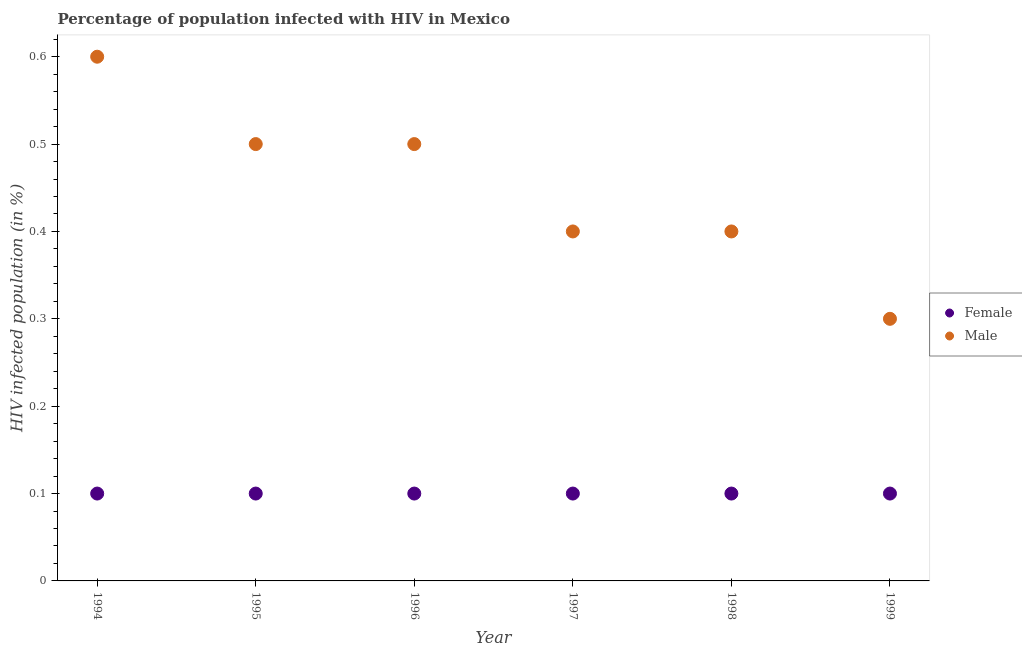How many different coloured dotlines are there?
Provide a short and direct response. 2. What is the percentage of males who are infected with hiv in 1997?
Give a very brief answer. 0.4. Across all years, what is the maximum percentage of males who are infected with hiv?
Offer a terse response. 0.6. Across all years, what is the minimum percentage of females who are infected with hiv?
Provide a short and direct response. 0.1. In which year was the percentage of females who are infected with hiv minimum?
Give a very brief answer. 1994. What is the total percentage of males who are infected with hiv in the graph?
Your response must be concise. 2.7. What is the difference between the percentage of males who are infected with hiv in 1994 and the percentage of females who are infected with hiv in 1996?
Provide a succinct answer. 0.5. What is the average percentage of males who are infected with hiv per year?
Make the answer very short. 0.45. In the year 1994, what is the difference between the percentage of females who are infected with hiv and percentage of males who are infected with hiv?
Offer a terse response. -0.5. In how many years, is the percentage of females who are infected with hiv greater than 0.16 %?
Make the answer very short. 0. Is the percentage of males who are infected with hiv in 1997 less than that in 1998?
Make the answer very short. No. Is the difference between the percentage of females who are infected with hiv in 1996 and 1998 greater than the difference between the percentage of males who are infected with hiv in 1996 and 1998?
Provide a succinct answer. No. What is the difference between the highest and the second highest percentage of females who are infected with hiv?
Your answer should be very brief. 0. What is the difference between the highest and the lowest percentage of males who are infected with hiv?
Give a very brief answer. 0.3. Is the sum of the percentage of males who are infected with hiv in 1996 and 1999 greater than the maximum percentage of females who are infected with hiv across all years?
Keep it short and to the point. Yes. Does the percentage of males who are infected with hiv monotonically increase over the years?
Your response must be concise. No. Is the percentage of males who are infected with hiv strictly greater than the percentage of females who are infected with hiv over the years?
Provide a succinct answer. Yes. Does the graph contain any zero values?
Ensure brevity in your answer.  No. Does the graph contain grids?
Your response must be concise. No. Where does the legend appear in the graph?
Ensure brevity in your answer.  Center right. How many legend labels are there?
Provide a succinct answer. 2. What is the title of the graph?
Keep it short and to the point. Percentage of population infected with HIV in Mexico. Does "Non-resident workers" appear as one of the legend labels in the graph?
Offer a terse response. No. What is the label or title of the X-axis?
Provide a succinct answer. Year. What is the label or title of the Y-axis?
Offer a very short reply. HIV infected population (in %). What is the HIV infected population (in %) in Male in 1996?
Your response must be concise. 0.5. What is the HIV infected population (in %) of Male in 1997?
Give a very brief answer. 0.4. What is the HIV infected population (in %) in Male in 1998?
Your answer should be very brief. 0.4. What is the HIV infected population (in %) of Female in 1999?
Your answer should be very brief. 0.1. Across all years, what is the minimum HIV infected population (in %) of Female?
Ensure brevity in your answer.  0.1. Across all years, what is the minimum HIV infected population (in %) in Male?
Your answer should be compact. 0.3. What is the total HIV infected population (in %) in Male in the graph?
Give a very brief answer. 2.7. What is the difference between the HIV infected population (in %) of Male in 1994 and that in 1995?
Keep it short and to the point. 0.1. What is the difference between the HIV infected population (in %) in Female in 1994 and that in 1996?
Provide a succinct answer. 0. What is the difference between the HIV infected population (in %) of Male in 1994 and that in 1996?
Provide a short and direct response. 0.1. What is the difference between the HIV infected population (in %) of Female in 1994 and that in 1997?
Ensure brevity in your answer.  0. What is the difference between the HIV infected population (in %) of Male in 1994 and that in 1997?
Provide a short and direct response. 0.2. What is the difference between the HIV infected population (in %) of Female in 1994 and that in 1998?
Keep it short and to the point. 0. What is the difference between the HIV infected population (in %) in Female in 1994 and that in 1999?
Give a very brief answer. 0. What is the difference between the HIV infected population (in %) in Male in 1994 and that in 1999?
Offer a very short reply. 0.3. What is the difference between the HIV infected population (in %) of Female in 1995 and that in 1996?
Ensure brevity in your answer.  0. What is the difference between the HIV infected population (in %) in Male in 1995 and that in 1996?
Ensure brevity in your answer.  0. What is the difference between the HIV infected population (in %) in Male in 1995 and that in 1997?
Provide a short and direct response. 0.1. What is the difference between the HIV infected population (in %) in Female in 1995 and that in 1998?
Make the answer very short. 0. What is the difference between the HIV infected population (in %) in Male in 1995 and that in 1999?
Offer a terse response. 0.2. What is the difference between the HIV infected population (in %) of Male in 1996 and that in 1997?
Offer a very short reply. 0.1. What is the difference between the HIV infected population (in %) of Female in 1996 and that in 1999?
Make the answer very short. 0. What is the difference between the HIV infected population (in %) of Male in 1997 and that in 1998?
Keep it short and to the point. 0. What is the difference between the HIV infected population (in %) in Female in 1997 and that in 1999?
Your answer should be very brief. 0. What is the difference between the HIV infected population (in %) of Female in 1998 and that in 1999?
Your response must be concise. 0. What is the difference between the HIV infected population (in %) of Female in 1994 and the HIV infected population (in %) of Male in 1995?
Give a very brief answer. -0.4. What is the difference between the HIV infected population (in %) of Female in 1994 and the HIV infected population (in %) of Male in 1996?
Your response must be concise. -0.4. What is the difference between the HIV infected population (in %) in Female in 1994 and the HIV infected population (in %) in Male in 1999?
Provide a succinct answer. -0.2. What is the difference between the HIV infected population (in %) of Female in 1995 and the HIV infected population (in %) of Male in 1996?
Offer a very short reply. -0.4. What is the difference between the HIV infected population (in %) of Female in 1995 and the HIV infected population (in %) of Male in 1997?
Your answer should be very brief. -0.3. What is the difference between the HIV infected population (in %) in Female in 1995 and the HIV infected population (in %) in Male in 1998?
Make the answer very short. -0.3. What is the difference between the HIV infected population (in %) of Female in 1995 and the HIV infected population (in %) of Male in 1999?
Your response must be concise. -0.2. What is the difference between the HIV infected population (in %) in Female in 1996 and the HIV infected population (in %) in Male in 1997?
Ensure brevity in your answer.  -0.3. What is the difference between the HIV infected population (in %) in Female in 1996 and the HIV infected population (in %) in Male in 1999?
Keep it short and to the point. -0.2. What is the average HIV infected population (in %) of Female per year?
Give a very brief answer. 0.1. What is the average HIV infected population (in %) of Male per year?
Offer a terse response. 0.45. In the year 1997, what is the difference between the HIV infected population (in %) of Female and HIV infected population (in %) of Male?
Your response must be concise. -0.3. In the year 1998, what is the difference between the HIV infected population (in %) in Female and HIV infected population (in %) in Male?
Your answer should be compact. -0.3. What is the ratio of the HIV infected population (in %) of Female in 1994 to that in 1995?
Provide a succinct answer. 1. What is the ratio of the HIV infected population (in %) of Female in 1994 to that in 1996?
Ensure brevity in your answer.  1. What is the ratio of the HIV infected population (in %) of Male in 1994 to that in 1996?
Keep it short and to the point. 1.2. What is the ratio of the HIV infected population (in %) in Female in 1994 to that in 1998?
Your answer should be very brief. 1. What is the ratio of the HIV infected population (in %) in Female in 1994 to that in 1999?
Your answer should be very brief. 1. What is the ratio of the HIV infected population (in %) of Female in 1995 to that in 1997?
Make the answer very short. 1. What is the ratio of the HIV infected population (in %) in Male in 1995 to that in 1997?
Ensure brevity in your answer.  1.25. What is the ratio of the HIV infected population (in %) in Female in 1995 to that in 1998?
Offer a very short reply. 1. What is the ratio of the HIV infected population (in %) in Female in 1995 to that in 1999?
Your answer should be compact. 1. What is the ratio of the HIV infected population (in %) in Male in 1996 to that in 1997?
Your answer should be compact. 1.25. What is the ratio of the HIV infected population (in %) of Female in 1996 to that in 1998?
Keep it short and to the point. 1. What is the ratio of the HIV infected population (in %) in Male in 1996 to that in 1998?
Offer a very short reply. 1.25. What is the ratio of the HIV infected population (in %) of Female in 1996 to that in 1999?
Your answer should be very brief. 1. What is the ratio of the HIV infected population (in %) of Male in 1996 to that in 1999?
Your answer should be compact. 1.67. What is the ratio of the HIV infected population (in %) of Male in 1997 to that in 1998?
Make the answer very short. 1. What is the ratio of the HIV infected population (in %) of Male in 1997 to that in 1999?
Your answer should be very brief. 1.33. What is the ratio of the HIV infected population (in %) of Female in 1998 to that in 1999?
Offer a very short reply. 1. What is the ratio of the HIV infected population (in %) of Male in 1998 to that in 1999?
Provide a short and direct response. 1.33. What is the difference between the highest and the second highest HIV infected population (in %) of Male?
Provide a succinct answer. 0.1. 